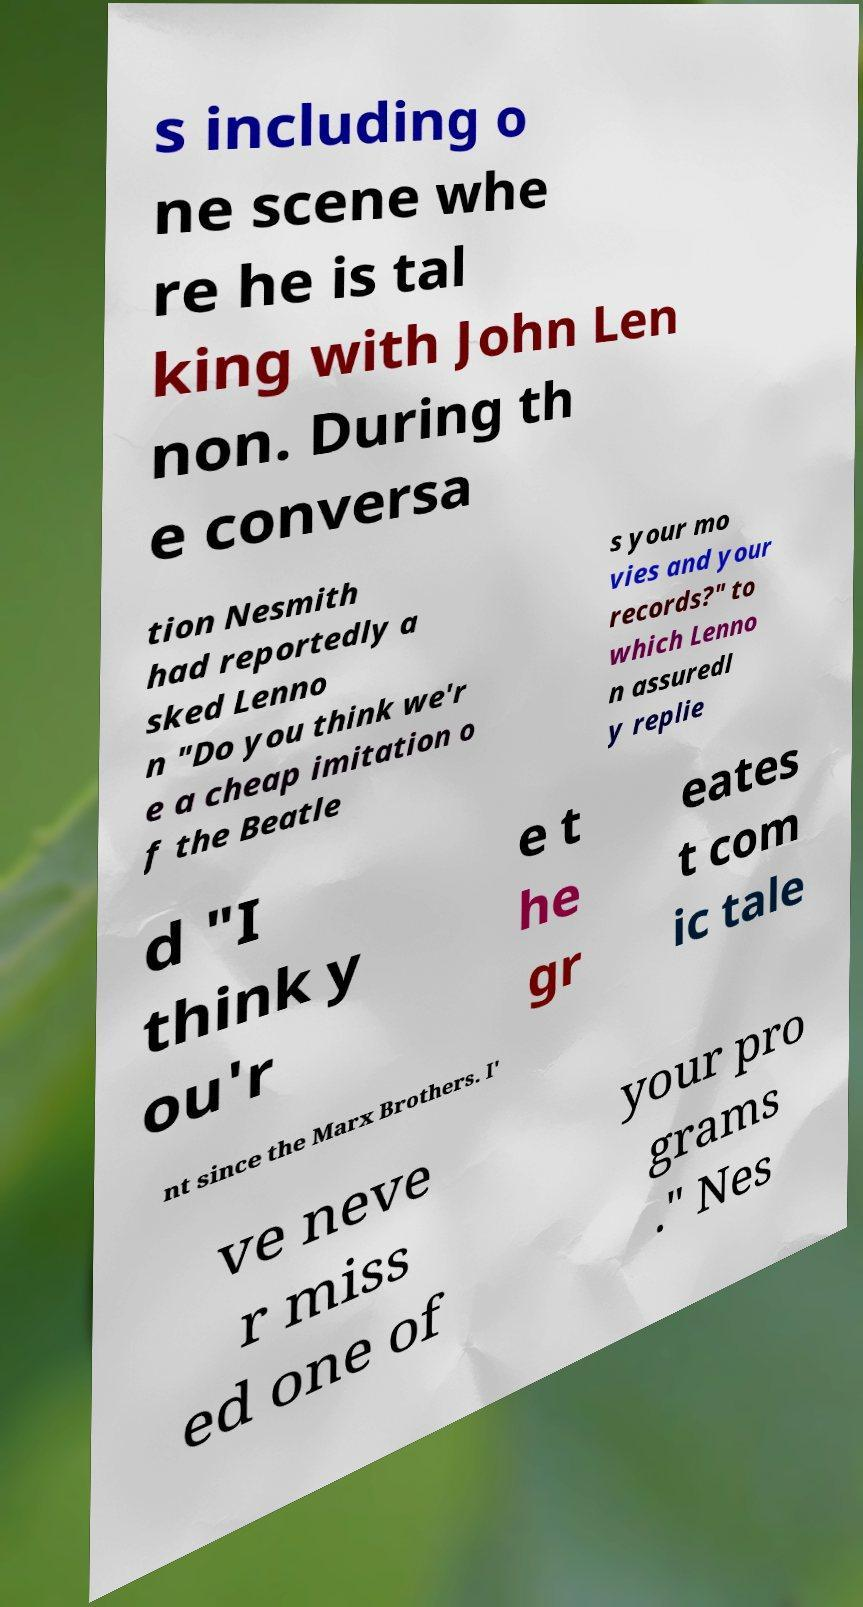There's text embedded in this image that I need extracted. Can you transcribe it verbatim? s including o ne scene whe re he is tal king with John Len non. During th e conversa tion Nesmith had reportedly a sked Lenno n "Do you think we'r e a cheap imitation o f the Beatle s your mo vies and your records?" to which Lenno n assuredl y replie d "I think y ou'r e t he gr eates t com ic tale nt since the Marx Brothers. I' ve neve r miss ed one of your pro grams ." Nes 